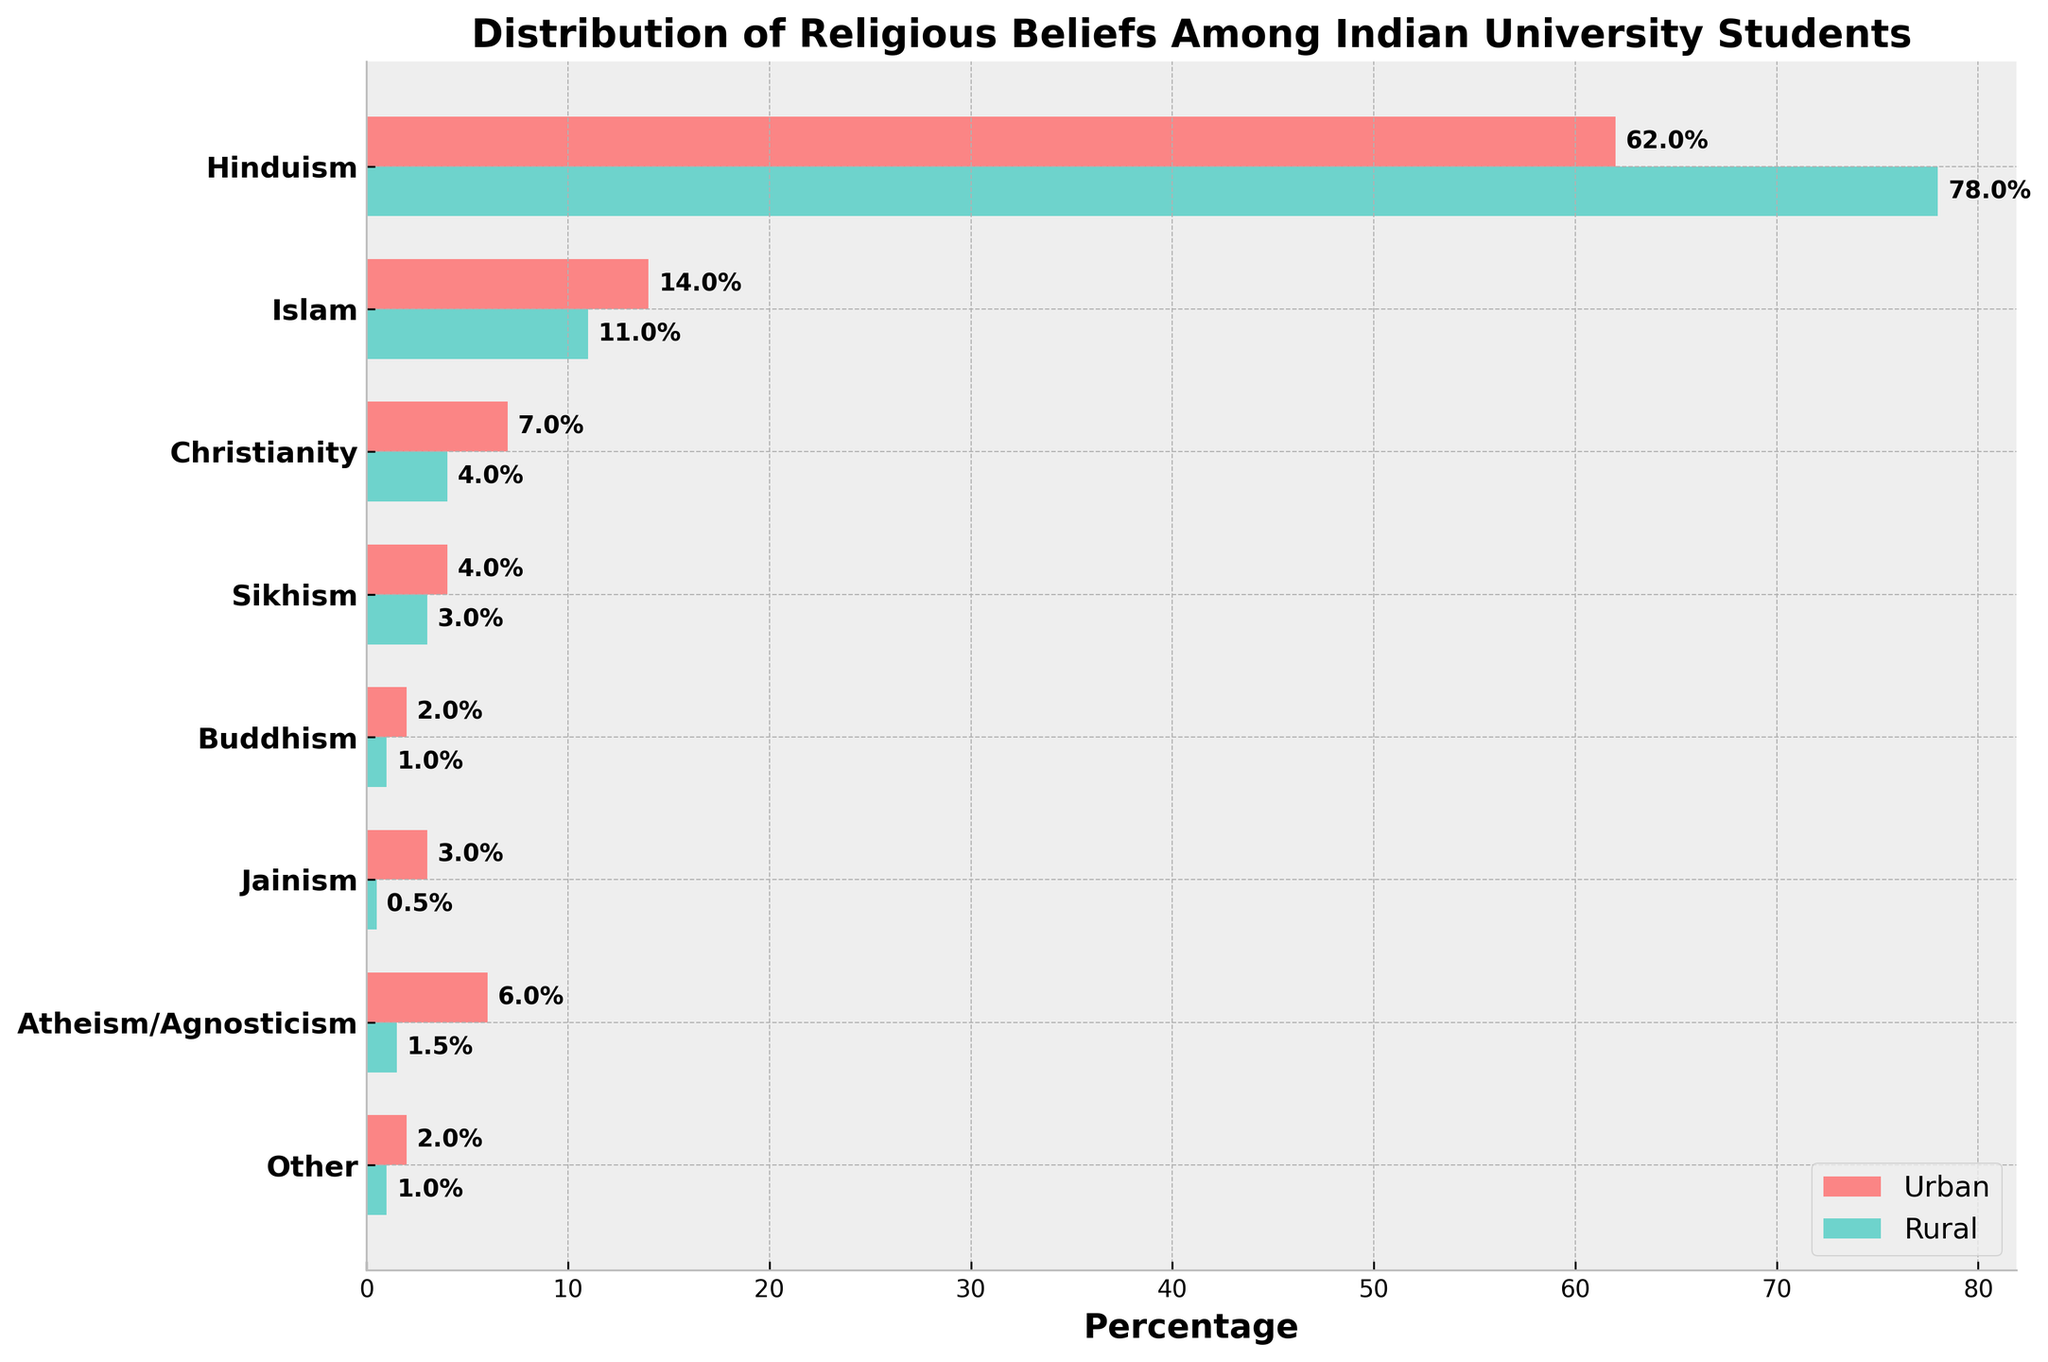What's the percentage of urban students who identify as Hindu? To determine the percentage of urban students who identify as Hindu, look for the relevant bar labeled 'Hinduism' in the urban section and read the value indicated.
Answer: 62% What's the difference in percentages between rural and urban students who identify as Atheist/Agnostic? For comparison, note the urban percentage of 6% and the rural percentage of 1.5%. Subtract the rural percentage from the urban percentage.
Answer: 4.5% Which religious belief has the least percentage representation among rural students? To find the least represented belief among rural students, compare the percentages listed for each belief in the rural section and identify the smallest number.
Answer: Jainism What is the sum of percentages for urban students identifying as Sikhism and Jainism? Add the percentage of urban students identifying as Sikhism (4%) to the percentage of those identifying as Jainism (3%).
Answer: 7% Are there more urban or rural students identifying as Islam? Check the percentages for urban and rural students identifying as Islam. The urban figure is 14%, while the rural figure is 11%.
Answer: Urban What is the combined percentage of urban and rural students who identify as Christianity? Add the percentage of urban students identifying as Christianity (7%) to the percentage of rural students identifying as Christianity (4%).
Answer: 11% Which background (urban or rural) has a higher representation of Buddhists among students? Compare the percentages for Buddhists in both backgrounds. The urban figure is 2%, and the rural figure is 1%.
Answer: Urban How much higher is the percentage of rural students who identify as Hindu compared to urban students? Subtract the percentage of urban Hindus (62%) from rural Hindus (78%).
Answer: 16% What is the title of the plot? Look at the text displayed at the top of the plot, indicating the subject of the figure.
Answer: Distribution of Religious Beliefs Among Indian University Students Which two religious beliefs have exactly a 1% difference between urban and rural backgrounds? Compare each pair of percentages for urban and rural backgrounds to find differences of 1%. Islam (14% urban, 11% rural) and Sikhism (4% urban, 3% rural) meet this criterion.
Answer: Islam and Sikhism 